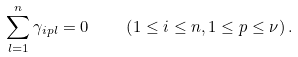<formula> <loc_0><loc_0><loc_500><loc_500>\sum _ { l = 1 } ^ { n } \gamma _ { i p l } = 0 \quad \left ( 1 \leq i \leq n , 1 \leq p \leq \nu \right ) .</formula> 